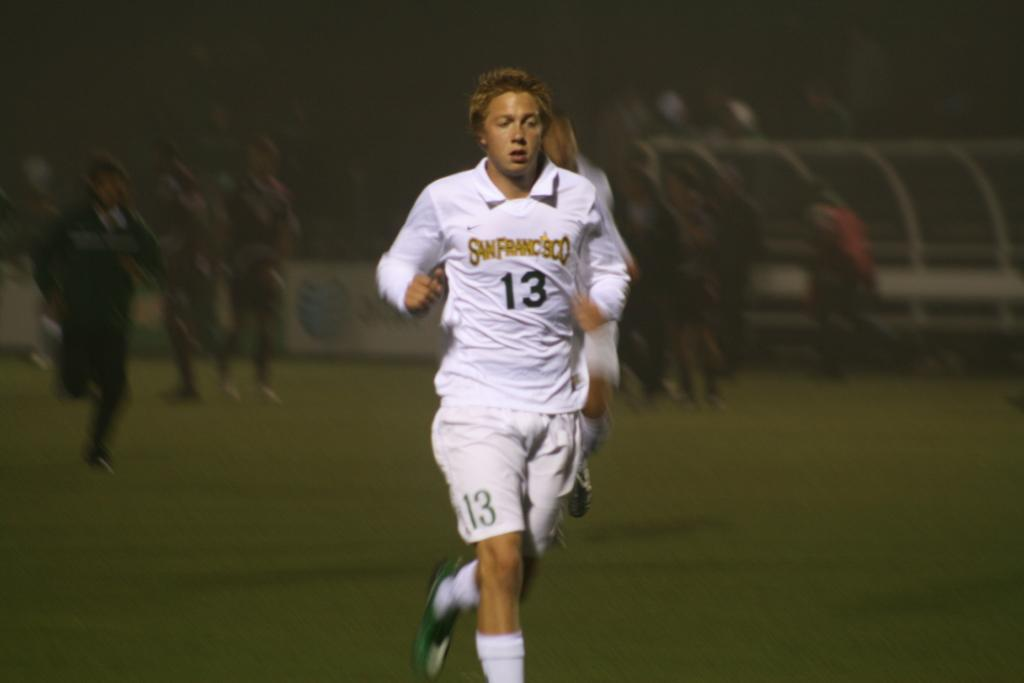<image>
Relay a brief, clear account of the picture shown. A runner wearing a San Fransisco shirt with the number 13 on it. 